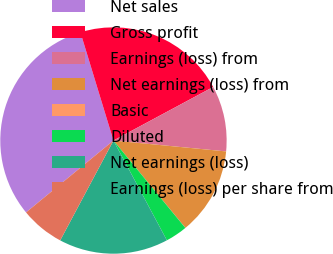Convert chart to OTSL. <chart><loc_0><loc_0><loc_500><loc_500><pie_chart><fcel>Net sales<fcel>Gross profit<fcel>Earnings (loss) from<fcel>Net earnings (loss) from<fcel>Basic<fcel>Diluted<fcel>Net earnings (loss)<fcel>Earnings (loss) per share from<nl><fcel>31.24%<fcel>21.87%<fcel>9.38%<fcel>12.5%<fcel>0.01%<fcel>3.13%<fcel>15.62%<fcel>6.25%<nl></chart> 